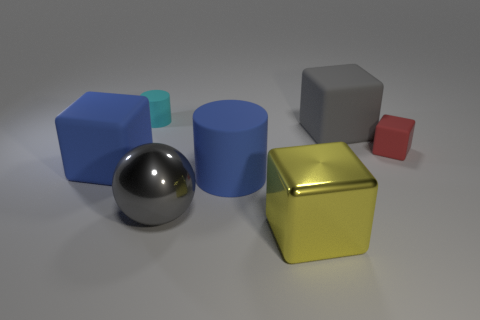What is the shape of the tiny thing that is right of the metal sphere that is in front of the blue rubber cylinder?
Your answer should be compact. Cube. How big is the gray object behind the tiny matte thing on the right side of the large yellow shiny cube?
Your response must be concise. Large. The big shiny thing that is to the left of the yellow object is what color?
Your response must be concise. Gray. There is a red block that is made of the same material as the cyan cylinder; what is its size?
Your answer should be compact. Small. How many green objects are the same shape as the tiny cyan thing?
Ensure brevity in your answer.  0. There is another thing that is the same size as the red matte object; what is its material?
Your response must be concise. Rubber. Is there another thing that has the same material as the big yellow object?
Your answer should be compact. Yes. The matte thing that is both to the right of the large gray shiny thing and to the left of the big yellow metallic cube is what color?
Offer a very short reply. Blue. How many other things are there of the same color as the tiny cylinder?
Keep it short and to the point. 0. The cylinder that is behind the small red rubber block that is on the right side of the blue matte cylinder to the right of the big ball is made of what material?
Offer a very short reply. Rubber. 